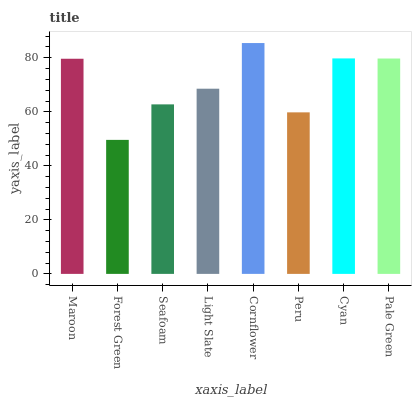Is Forest Green the minimum?
Answer yes or no. Yes. Is Cornflower the maximum?
Answer yes or no. Yes. Is Seafoam the minimum?
Answer yes or no. No. Is Seafoam the maximum?
Answer yes or no. No. Is Seafoam greater than Forest Green?
Answer yes or no. Yes. Is Forest Green less than Seafoam?
Answer yes or no. Yes. Is Forest Green greater than Seafoam?
Answer yes or no. No. Is Seafoam less than Forest Green?
Answer yes or no. No. Is Maroon the high median?
Answer yes or no. Yes. Is Light Slate the low median?
Answer yes or no. Yes. Is Forest Green the high median?
Answer yes or no. No. Is Cyan the low median?
Answer yes or no. No. 